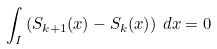<formula> <loc_0><loc_0><loc_500><loc_500>\int _ { I } \left ( S _ { k + 1 } ( x ) - S _ { k } ( x ) \right ) \, d x = 0</formula> 